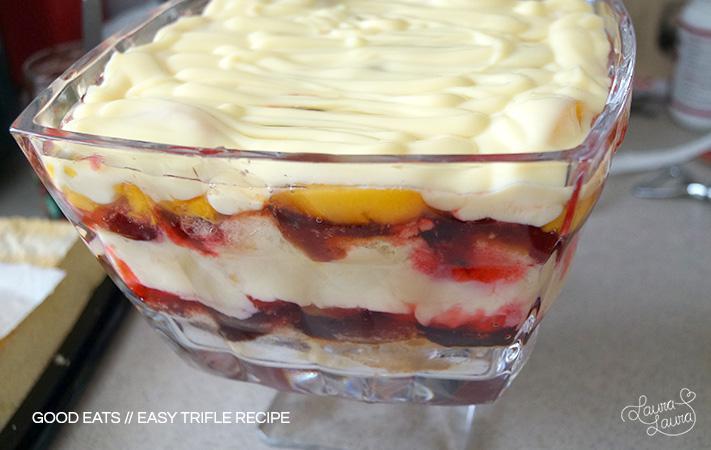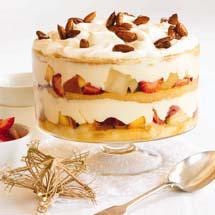The first image is the image on the left, the second image is the image on the right. Evaluate the accuracy of this statement regarding the images: "An image shows a dessert garnished with red fruit that features jelly roll slices around the outer edge.". Is it true? Answer yes or no. No. The first image is the image on the left, the second image is the image on the right. For the images shown, is this caption "The cake in the image on the right has several layers." true? Answer yes or no. Yes. 